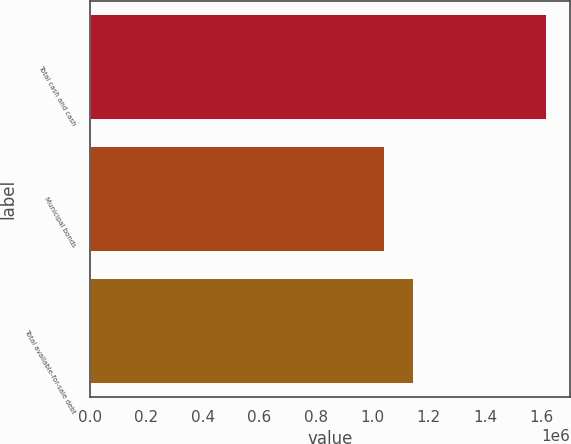Convert chart. <chart><loc_0><loc_0><loc_500><loc_500><bar_chart><fcel>Total cash and cash<fcel>Municipal bonds<fcel>Total available-for-sale debt<nl><fcel>1.61818e+06<fcel>1.04379e+06<fcel>1.14866e+06<nl></chart> 